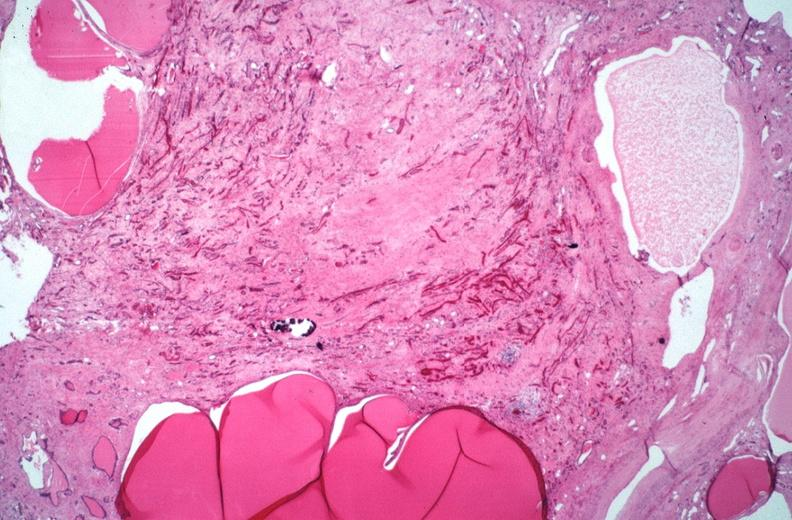what does this image show?
Answer the question using a single word or phrase. Kidney 